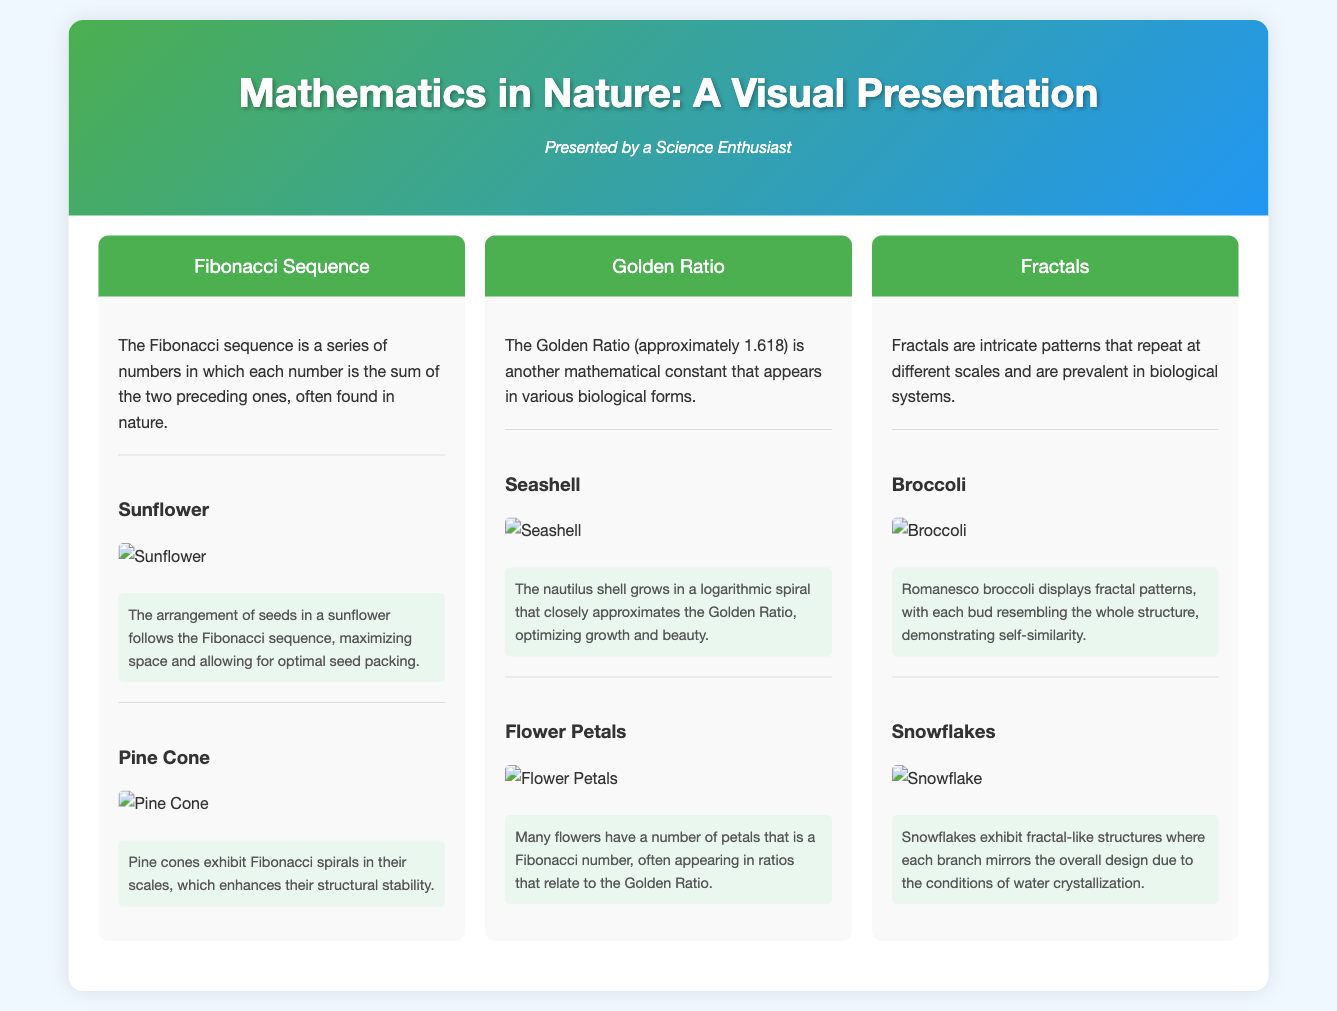What is the mathematical sequence found in sunflowers? The document states that the arrangement of seeds in a sunflower follows the Fibonacci sequence.
Answer: Fibonacci sequence Which mathematical constant is approximately 1.618? This constant is known as the Golden Ratio, which is mentioned in the document.
Answer: Golden Ratio What is a natural example of fractals mentioned in the document? The document mentions Romanesco broccoli displaying fractal patterns as an example.
Answer: Broccoli How do seashells grow according to the document? The document describes nautilus shells growing in a logarithmic spiral that approximates the Golden Ratio.
Answer: Logarithmic spiral What pattern do snowflakes exhibit? The document states that snowflakes exhibit fractal-like structures due to water crystallization conditions.
Answer: Fractal-like structures What type of mathematical pattern do pine cones showcase? The document notes that pine cones exhibit Fibonacci spirals in their scales.
Answer: Fibonacci spirals How many petals do many flowers have in relation to Fibonacci numbers? The document indicates that many flowers have a number of petals that is a Fibonacci number.
Answer: A Fibonacci number What is shown by the arrangement of seeds in a sunflower? The arrangement of seeds in sunflowers maximizes space and allows for optimal seed packing according to the document.
Answer: Maximizes space Which two natural phenomena relate to the Golden Ratio? The document mentions seashells and flower petals as examples relating to the Golden Ratio.
Answer: Seashells and flower petals 